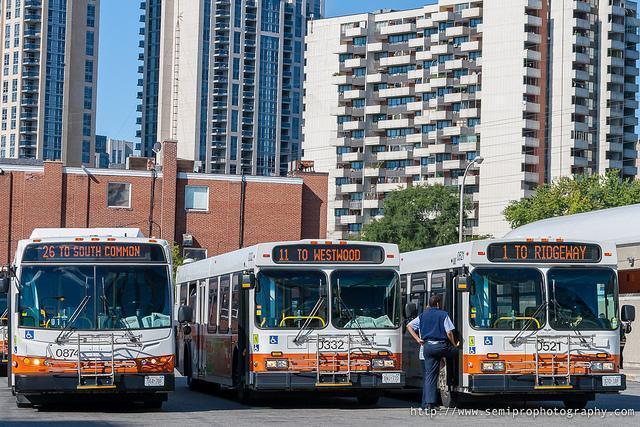How many buses are there?
Give a very brief answer. 3. How many buses can you see?
Give a very brief answer. 3. How many train cars are under the poles?
Give a very brief answer. 0. 